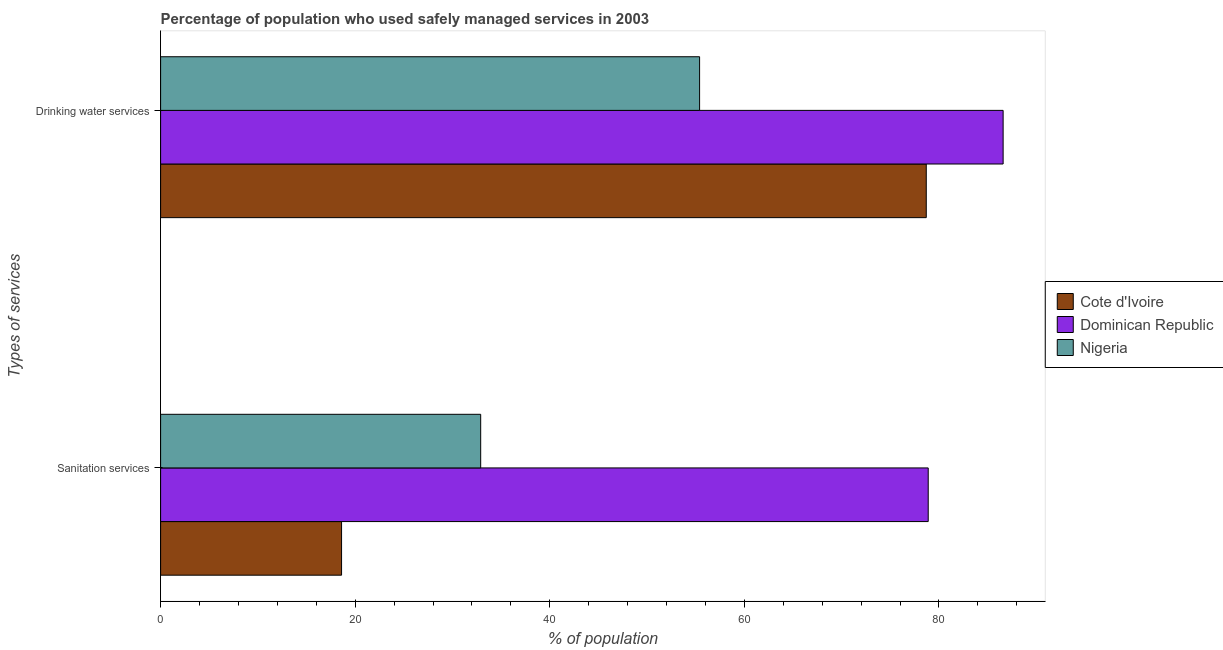Are the number of bars per tick equal to the number of legend labels?
Your answer should be compact. Yes. Are the number of bars on each tick of the Y-axis equal?
Give a very brief answer. Yes. How many bars are there on the 2nd tick from the bottom?
Offer a terse response. 3. What is the label of the 2nd group of bars from the top?
Your answer should be compact. Sanitation services. What is the percentage of population who used drinking water services in Nigeria?
Ensure brevity in your answer.  55.4. Across all countries, what is the maximum percentage of population who used sanitation services?
Provide a short and direct response. 78.9. In which country was the percentage of population who used drinking water services maximum?
Your response must be concise. Dominican Republic. In which country was the percentage of population who used drinking water services minimum?
Your answer should be compact. Nigeria. What is the total percentage of population who used drinking water services in the graph?
Your answer should be very brief. 220.7. What is the difference between the percentage of population who used drinking water services in Cote d'Ivoire and that in Dominican Republic?
Provide a succinct answer. -7.9. What is the difference between the percentage of population who used drinking water services in Dominican Republic and the percentage of population who used sanitation services in Nigeria?
Provide a succinct answer. 53.7. What is the average percentage of population who used sanitation services per country?
Ensure brevity in your answer.  43.47. What is the difference between the percentage of population who used sanitation services and percentage of population who used drinking water services in Nigeria?
Your response must be concise. -22.5. In how many countries, is the percentage of population who used drinking water services greater than 4 %?
Offer a very short reply. 3. What is the ratio of the percentage of population who used sanitation services in Dominican Republic to that in Cote d'Ivoire?
Offer a terse response. 4.24. In how many countries, is the percentage of population who used sanitation services greater than the average percentage of population who used sanitation services taken over all countries?
Offer a terse response. 1. What does the 1st bar from the top in Sanitation services represents?
Ensure brevity in your answer.  Nigeria. What does the 3rd bar from the bottom in Drinking water services represents?
Your answer should be compact. Nigeria. What is the difference between two consecutive major ticks on the X-axis?
Your answer should be compact. 20. Does the graph contain any zero values?
Your response must be concise. No. How are the legend labels stacked?
Ensure brevity in your answer.  Vertical. What is the title of the graph?
Your response must be concise. Percentage of population who used safely managed services in 2003. Does "Aruba" appear as one of the legend labels in the graph?
Provide a short and direct response. No. What is the label or title of the X-axis?
Give a very brief answer. % of population. What is the label or title of the Y-axis?
Your answer should be compact. Types of services. What is the % of population in Cote d'Ivoire in Sanitation services?
Give a very brief answer. 18.6. What is the % of population of Dominican Republic in Sanitation services?
Offer a very short reply. 78.9. What is the % of population in Nigeria in Sanitation services?
Make the answer very short. 32.9. What is the % of population of Cote d'Ivoire in Drinking water services?
Offer a terse response. 78.7. What is the % of population of Dominican Republic in Drinking water services?
Your answer should be very brief. 86.6. What is the % of population of Nigeria in Drinking water services?
Keep it short and to the point. 55.4. Across all Types of services, what is the maximum % of population of Cote d'Ivoire?
Keep it short and to the point. 78.7. Across all Types of services, what is the maximum % of population in Dominican Republic?
Make the answer very short. 86.6. Across all Types of services, what is the maximum % of population of Nigeria?
Offer a terse response. 55.4. Across all Types of services, what is the minimum % of population of Dominican Republic?
Your answer should be very brief. 78.9. Across all Types of services, what is the minimum % of population of Nigeria?
Your response must be concise. 32.9. What is the total % of population in Cote d'Ivoire in the graph?
Your answer should be compact. 97.3. What is the total % of population of Dominican Republic in the graph?
Your answer should be very brief. 165.5. What is the total % of population of Nigeria in the graph?
Offer a terse response. 88.3. What is the difference between the % of population of Cote d'Ivoire in Sanitation services and that in Drinking water services?
Ensure brevity in your answer.  -60.1. What is the difference between the % of population in Nigeria in Sanitation services and that in Drinking water services?
Your answer should be compact. -22.5. What is the difference between the % of population in Cote d'Ivoire in Sanitation services and the % of population in Dominican Republic in Drinking water services?
Provide a succinct answer. -68. What is the difference between the % of population of Cote d'Ivoire in Sanitation services and the % of population of Nigeria in Drinking water services?
Your response must be concise. -36.8. What is the average % of population of Cote d'Ivoire per Types of services?
Your answer should be very brief. 48.65. What is the average % of population of Dominican Republic per Types of services?
Your answer should be very brief. 82.75. What is the average % of population in Nigeria per Types of services?
Your answer should be very brief. 44.15. What is the difference between the % of population in Cote d'Ivoire and % of population in Dominican Republic in Sanitation services?
Your answer should be very brief. -60.3. What is the difference between the % of population in Cote d'Ivoire and % of population in Nigeria in Sanitation services?
Provide a succinct answer. -14.3. What is the difference between the % of population in Dominican Republic and % of population in Nigeria in Sanitation services?
Provide a succinct answer. 46. What is the difference between the % of population of Cote d'Ivoire and % of population of Nigeria in Drinking water services?
Offer a terse response. 23.3. What is the difference between the % of population in Dominican Republic and % of population in Nigeria in Drinking water services?
Your response must be concise. 31.2. What is the ratio of the % of population of Cote d'Ivoire in Sanitation services to that in Drinking water services?
Your answer should be very brief. 0.24. What is the ratio of the % of population of Dominican Republic in Sanitation services to that in Drinking water services?
Keep it short and to the point. 0.91. What is the ratio of the % of population in Nigeria in Sanitation services to that in Drinking water services?
Give a very brief answer. 0.59. What is the difference between the highest and the second highest % of population of Cote d'Ivoire?
Offer a very short reply. 60.1. What is the difference between the highest and the second highest % of population of Nigeria?
Provide a short and direct response. 22.5. What is the difference between the highest and the lowest % of population in Cote d'Ivoire?
Provide a succinct answer. 60.1. What is the difference between the highest and the lowest % of population in Dominican Republic?
Your response must be concise. 7.7. What is the difference between the highest and the lowest % of population of Nigeria?
Provide a succinct answer. 22.5. 